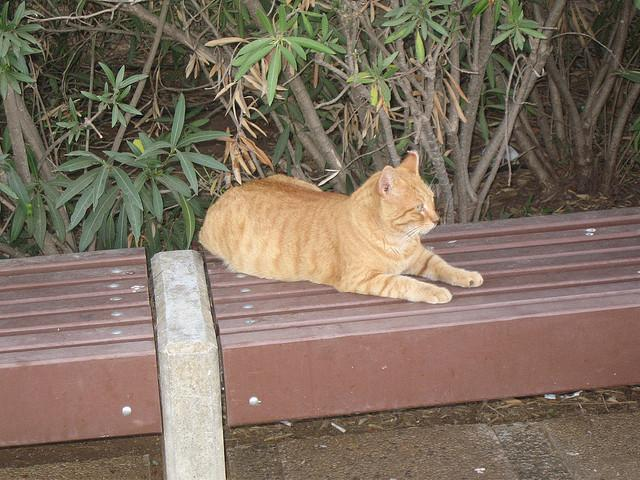What word describes this animal? Please explain your reasoning. feline. This is a feline cat. 